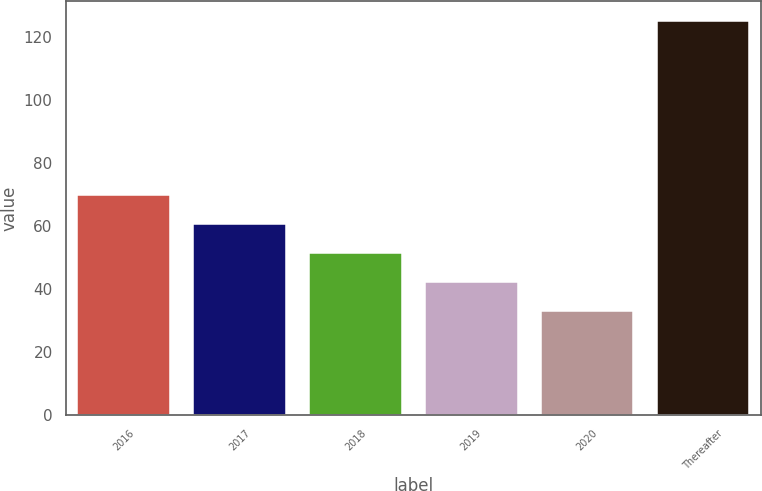Convert chart. <chart><loc_0><loc_0><loc_500><loc_500><bar_chart><fcel>2016<fcel>2017<fcel>2018<fcel>2019<fcel>2020<fcel>Thereafter<nl><fcel>69.8<fcel>60.6<fcel>51.4<fcel>42.2<fcel>33<fcel>125<nl></chart> 